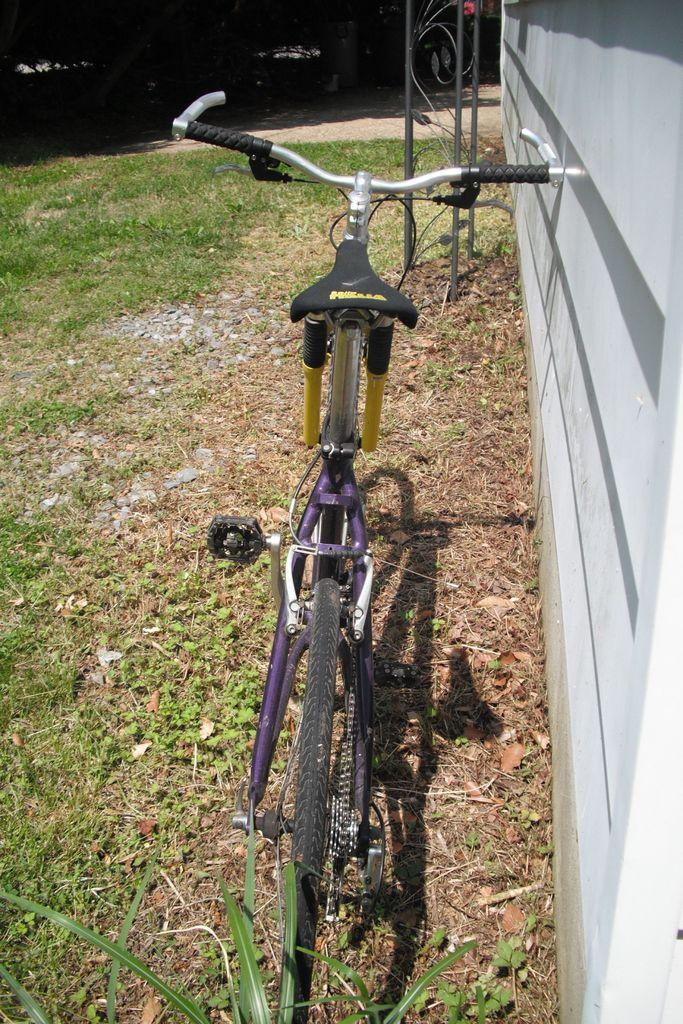What type of surface is visible in the image? There is grass on the surface in the image. What structure can be seen in the image? There is a wall in the image. What object is located beside the wall? There is a bicycle beside the wall. What are the rods in front of the bicycle used for? The purpose of the rods in front of the bicycle is not specified in the image. How many pigs are visible in the image? There are no pigs present in the image. What does the mom say to the child in the image? There is no mom or child present in the image. 